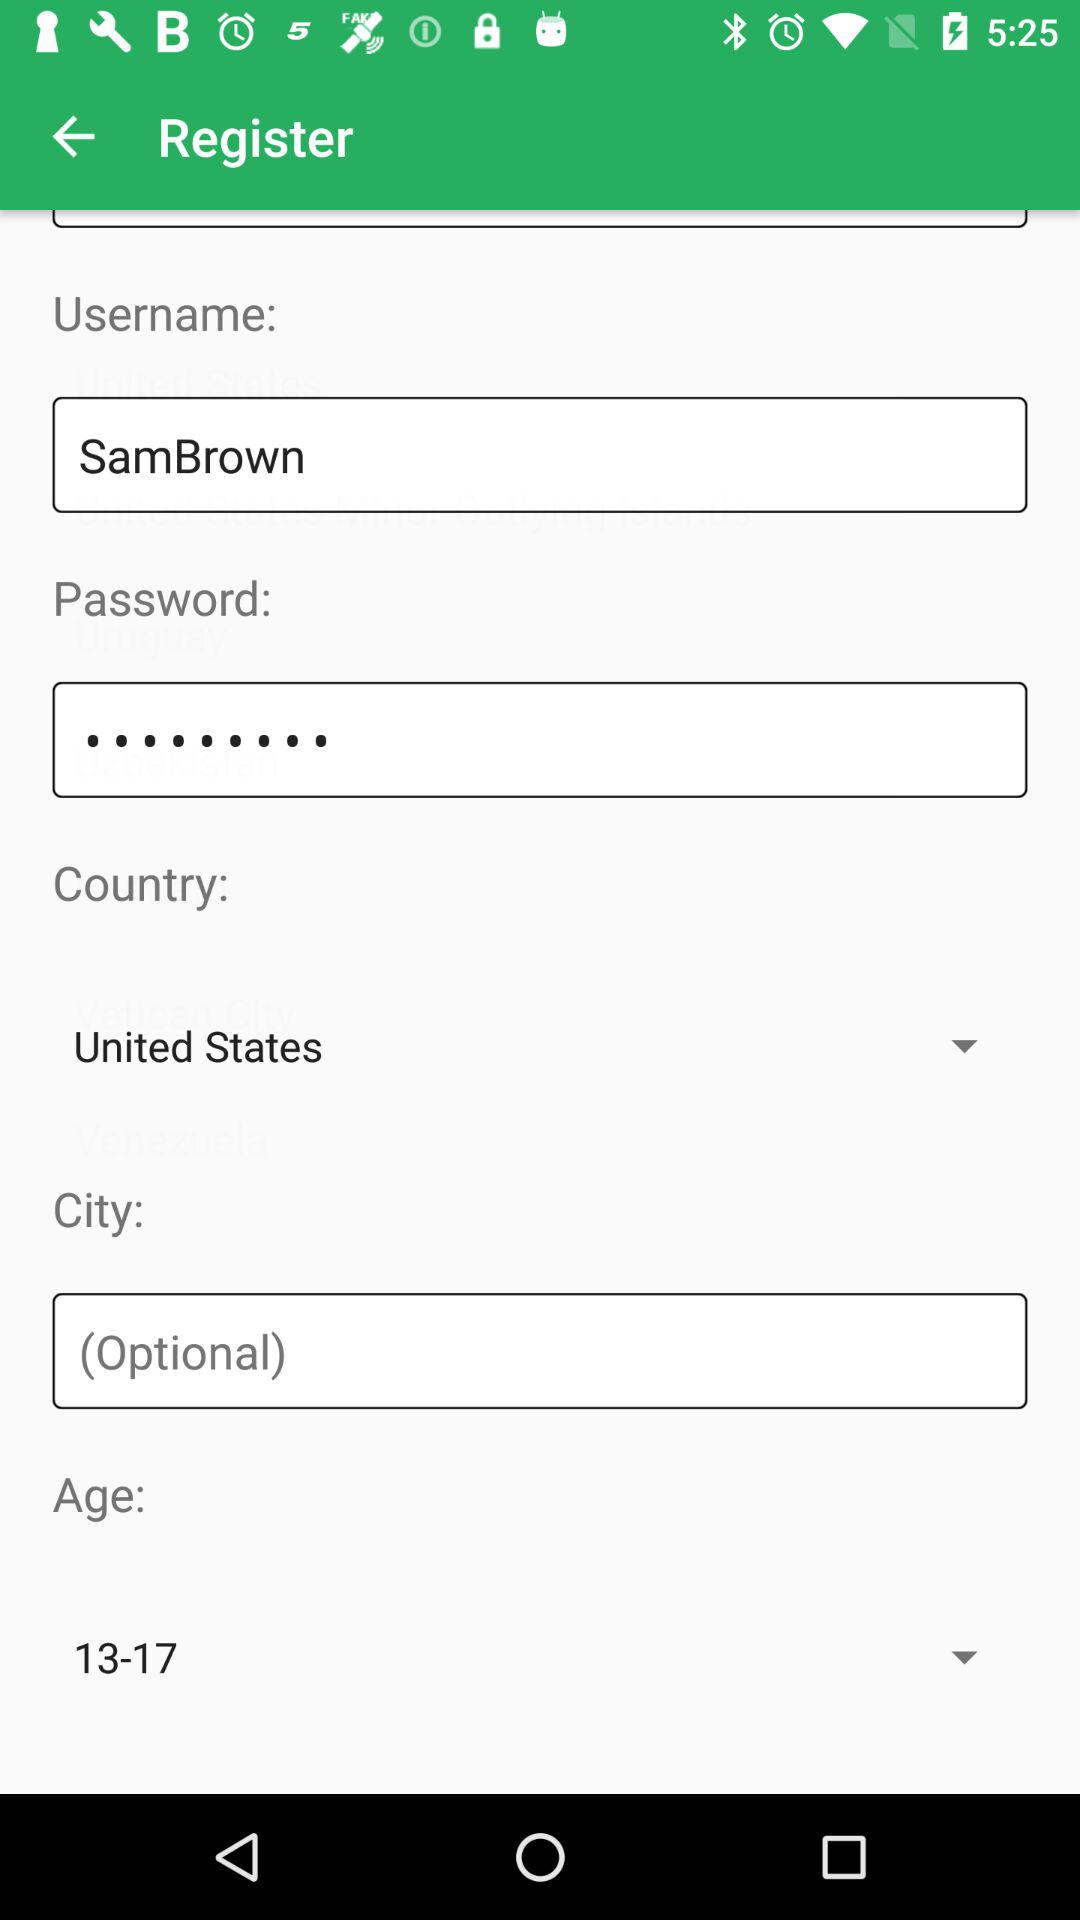How many characters are required to create a password?
When the provided information is insufficient, respond with <no answer>. <no answer> 